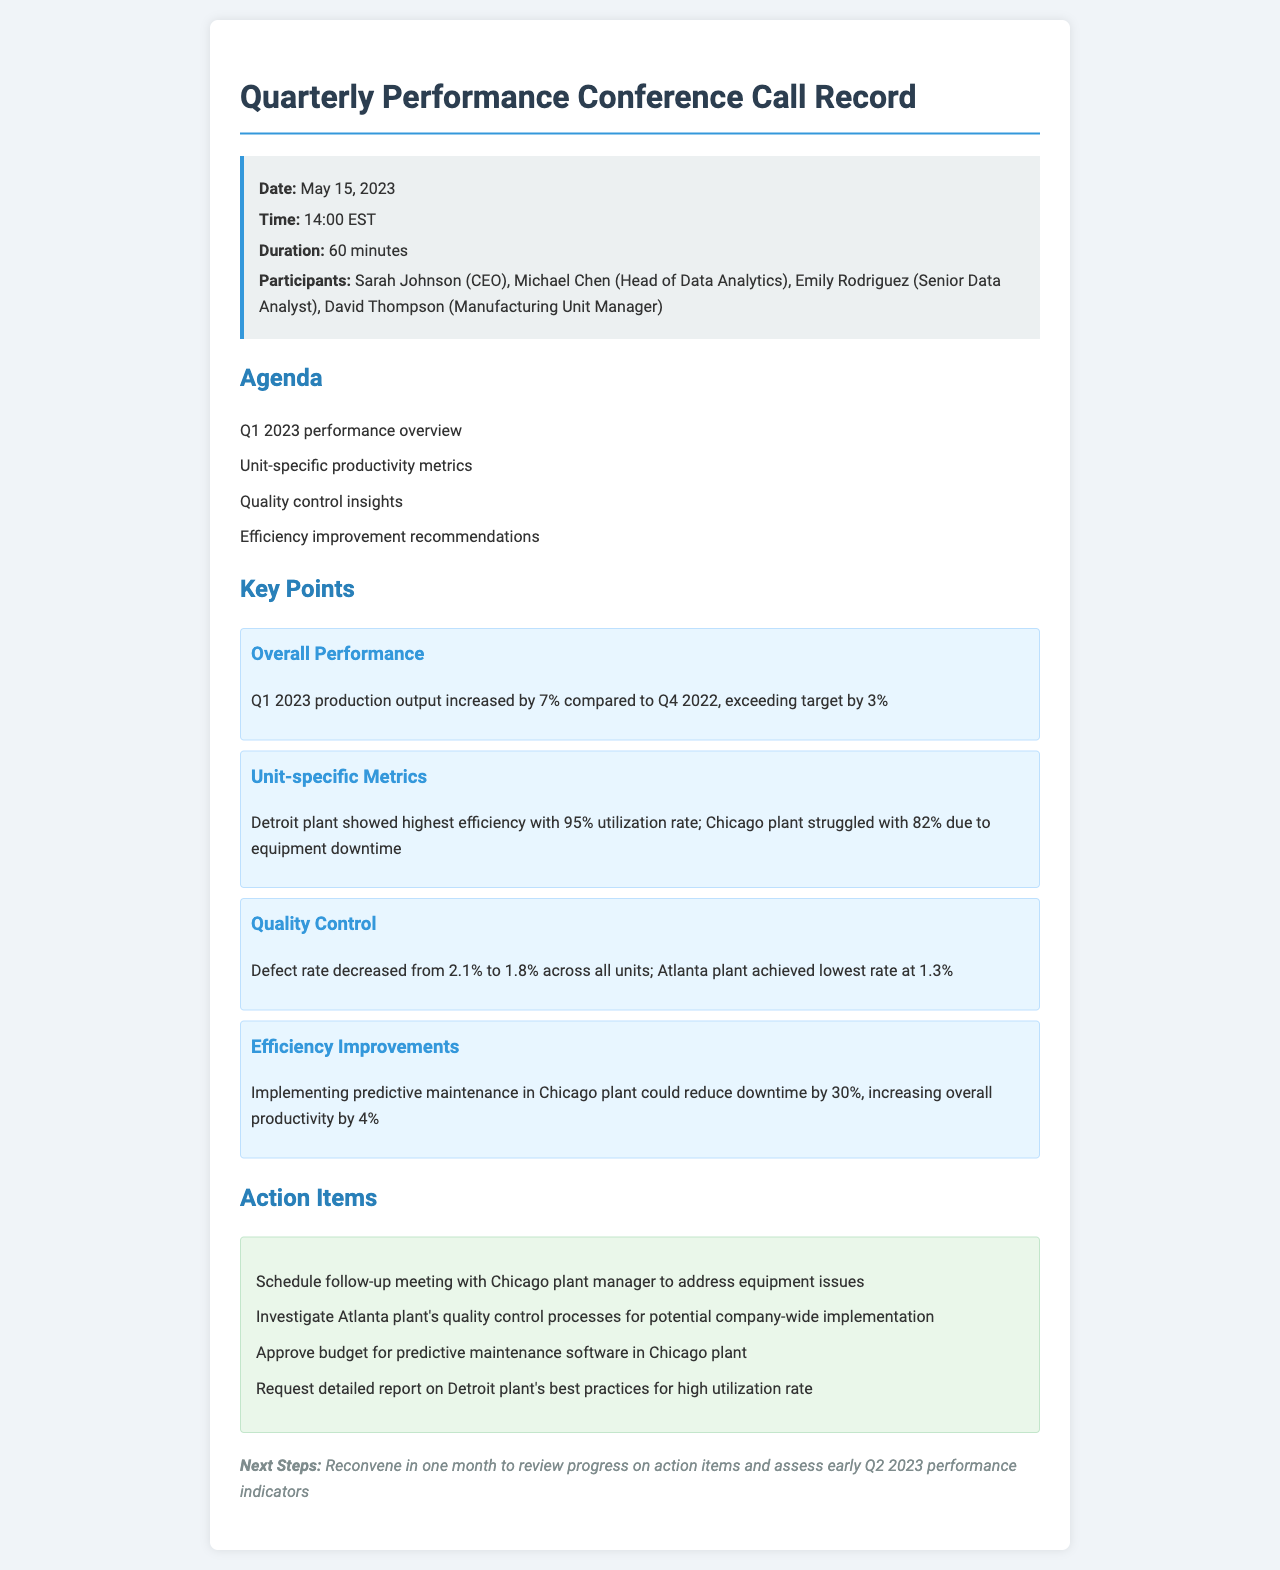What was the date of the conference call? The date of the conference call is specified in the call details section of the document.
Answer: May 15, 2023 What percentage did Q1 2023 production output increase? The document states the increase in production output compared to Q4 2022 in the key points section.
Answer: 7% Which plant showed the highest efficiency? The unit-specific metrics in the key points section highlight the plant with the highest efficiency.
Answer: Detroit plant What was the defect rate in the Atlanta plant? The quality control section mentions the defect rate specifically for the Atlanta plant.
Answer: 1.3% What action item involves the Chicago plant manager? The action items section lists tasks that need to be completed, including those related to the Chicago plant manager.
Answer: Schedule follow-up meeting Why is predictive maintenance being considered for the Chicago plant? The efficiency improvements section discusses the expected outcome of implementing predictive maintenance in the Chicago plant.
Answer: Reduce downtime by 30% 